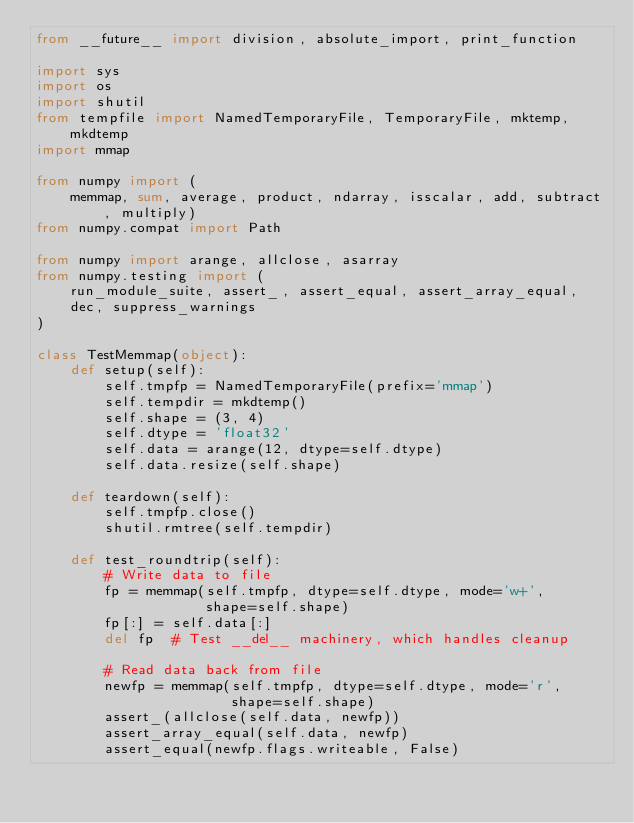<code> <loc_0><loc_0><loc_500><loc_500><_Python_>from __future__ import division, absolute_import, print_function

import sys
import os
import shutil
from tempfile import NamedTemporaryFile, TemporaryFile, mktemp, mkdtemp
import mmap

from numpy import (
    memmap, sum, average, product, ndarray, isscalar, add, subtract, multiply)
from numpy.compat import Path

from numpy import arange, allclose, asarray
from numpy.testing import (
    run_module_suite, assert_, assert_equal, assert_array_equal,
    dec, suppress_warnings
)

class TestMemmap(object):
    def setup(self):
        self.tmpfp = NamedTemporaryFile(prefix='mmap')
        self.tempdir = mkdtemp()
        self.shape = (3, 4)
        self.dtype = 'float32'
        self.data = arange(12, dtype=self.dtype)
        self.data.resize(self.shape)

    def teardown(self):
        self.tmpfp.close()
        shutil.rmtree(self.tempdir)

    def test_roundtrip(self):
        # Write data to file
        fp = memmap(self.tmpfp, dtype=self.dtype, mode='w+',
                    shape=self.shape)
        fp[:] = self.data[:]
        del fp  # Test __del__ machinery, which handles cleanup

        # Read data back from file
        newfp = memmap(self.tmpfp, dtype=self.dtype, mode='r',
                       shape=self.shape)
        assert_(allclose(self.data, newfp))
        assert_array_equal(self.data, newfp)
        assert_equal(newfp.flags.writeable, False)
</code> 